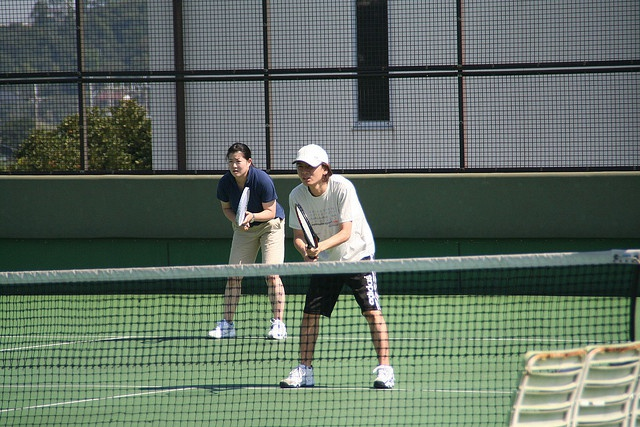Describe the objects in this image and their specific colors. I can see people in gray, white, black, and darkgray tones, people in gray, black, ivory, and darkgray tones, chair in gray, darkgray, and beige tones, chair in gray, darkgray, and beige tones, and tennis racket in gray, ivory, black, and darkgray tones in this image. 